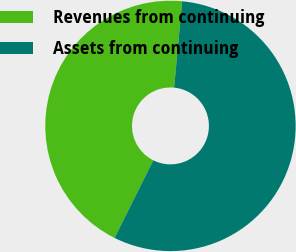Convert chart to OTSL. <chart><loc_0><loc_0><loc_500><loc_500><pie_chart><fcel>Revenues from continuing<fcel>Assets from continuing<nl><fcel>44.13%<fcel>55.87%<nl></chart> 